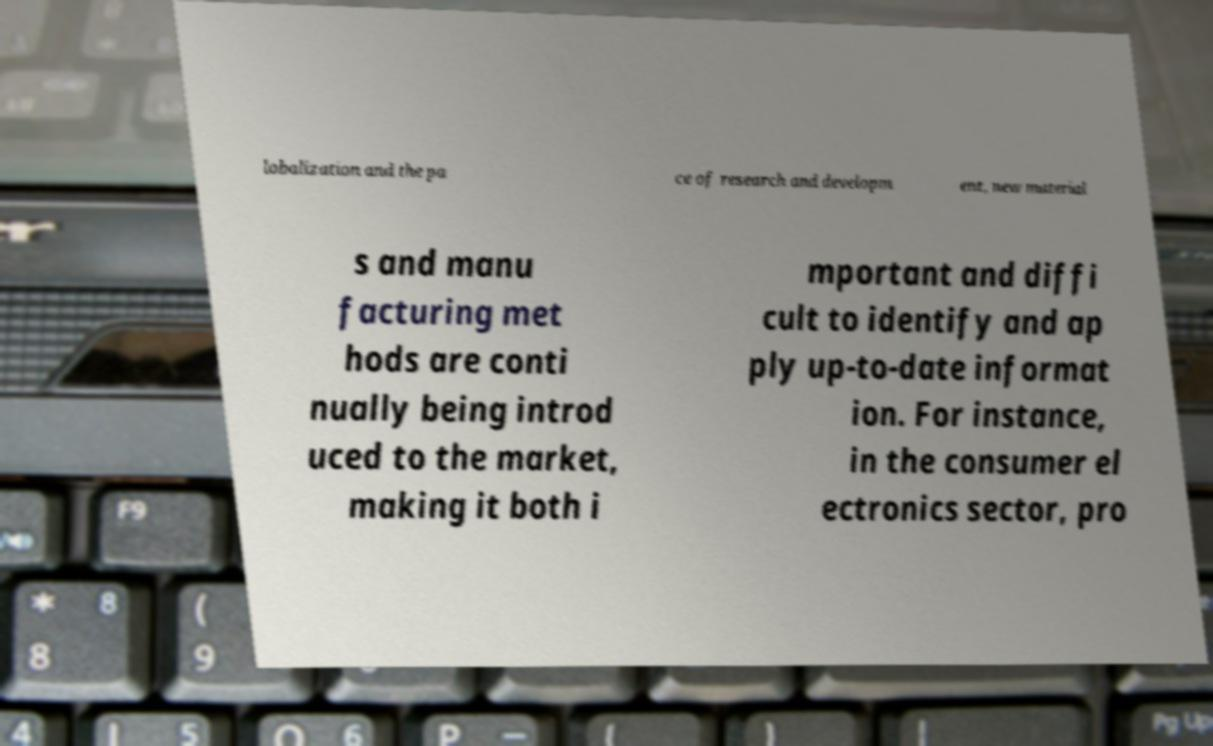I need the written content from this picture converted into text. Can you do that? lobalization and the pa ce of research and developm ent, new material s and manu facturing met hods are conti nually being introd uced to the market, making it both i mportant and diffi cult to identify and ap ply up-to-date informat ion. For instance, in the consumer el ectronics sector, pro 